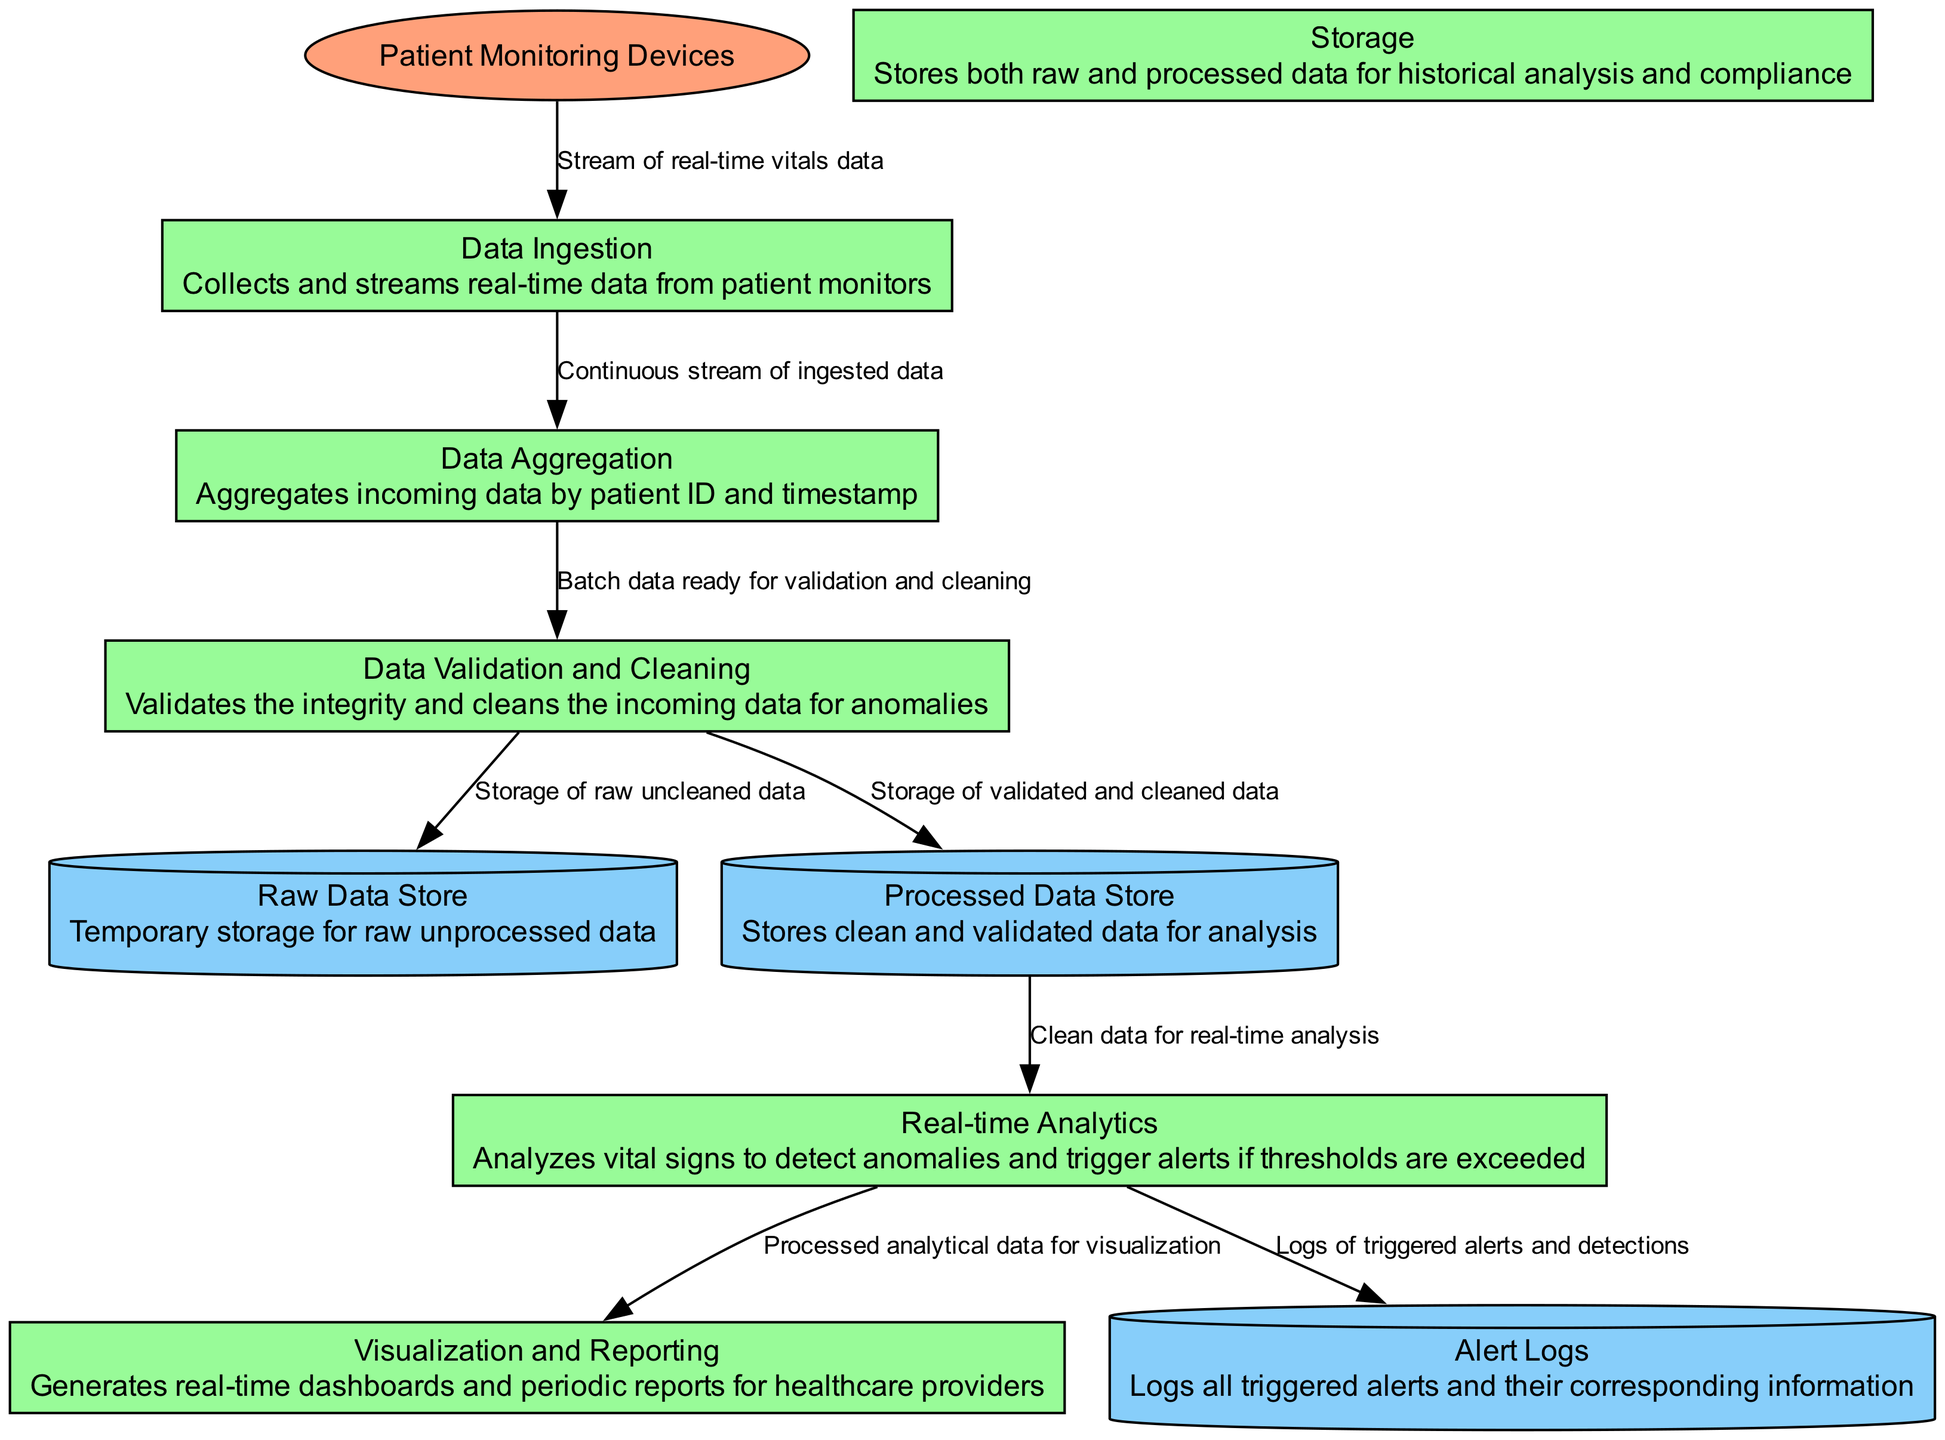What is the source of the data in this pipeline? The source of the data is indicated as "Patient Monitoring Devices," which are external entities collecting real-time patients' vital signs.
Answer: Patient Monitoring Devices How many processes are there in the diagram? By counting the listed processes in the diagram, there are six distinct processes: Data Ingestion, Data Aggregation, Data Validation and Cleaning, Real-time Analytics, Storage, and Visualization and Reporting.
Answer: Six What does the Data Validation and Cleaning process output to? The Data Validation and Cleaning process outputs to the Raw Data Store and the Processed Data Store, as indicated by the outgoing flows from this process in the diagram.
Answer: Raw Data Store and Processed Data Store Which process is responsible for analyzing vital signs? The Real-time Analytics process is specifically designed to analyze the vital signs for detecting anomalies and triggering alerts, as described.
Answer: Real-time Analytics What is stored in the Alert Logs? The Alert Logs are meant to store logs of all triggered alerts and their corresponding information as indicated in the flow descriptions leading to that data store.
Answer: Triggered alerts and corresponding information What happens to the clean data after the Data Validation and Cleaning process? After the Data Validation and Cleaning process, the clean data is sent to the Processed Data Store for storage, and then it is directed to the Real-time Analytics process for further analysis.
Answer: Sent to the Processed Data Store and Real-time Analytics What does the Visualization and Reporting process generate? The Visualization and Reporting process generates real-time dashboards and periodic reports specifically for healthcare providers, as stated in the description of this process.
Answer: Real-time dashboards and periodic reports From which process does the flow of data to the Storage process originate? The flow of data to the Storage process originates from the Data Validation and Cleaning process, which outputs the validated and cleaned data to be stored.
Answer: Data Validation and Cleaning What is the primary function of the Data Aggregation process? The primary function of the Data Aggregation process is to aggregate incoming data by patient ID and timestamp, enabling organized processing of the data stream.
Answer: Aggregate data by patient ID and timestamp 